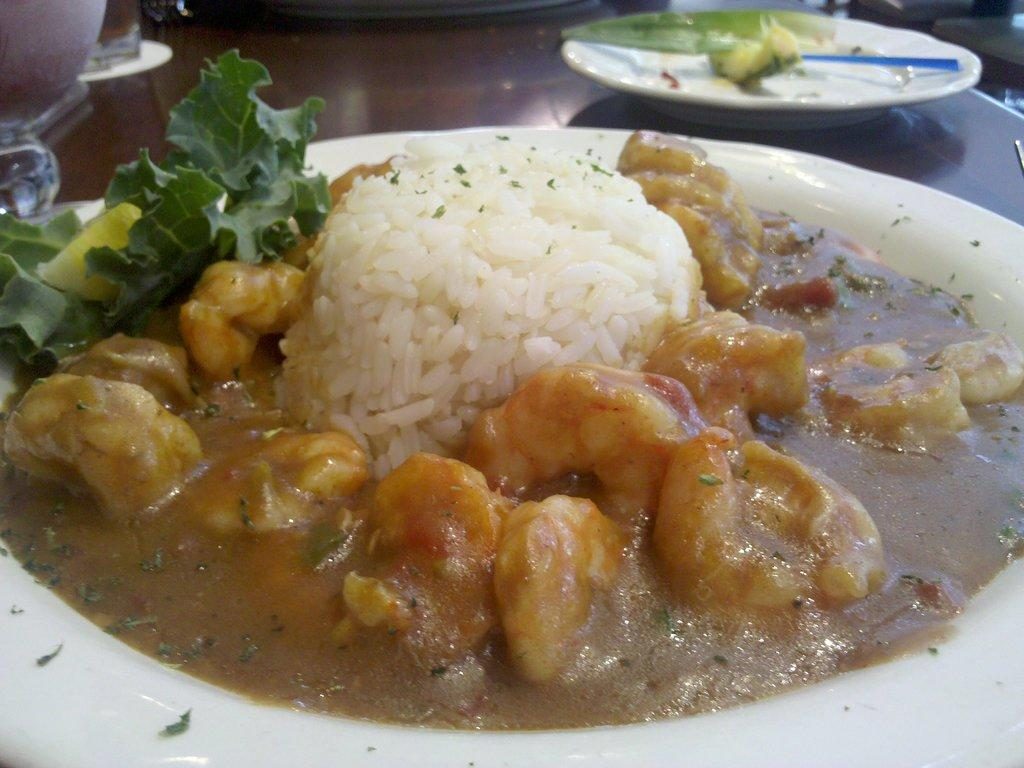What is present on the surface in the image? There are food items on plates in the image. What is the color of the surface the plates are on? The surface is brown in color. What colors can be seen in the food items? The food has white, green, and brown colors. What type of force is being applied to the desk in the image? There is no desk present in the image, so it is not possible to determine if any force is being applied. 